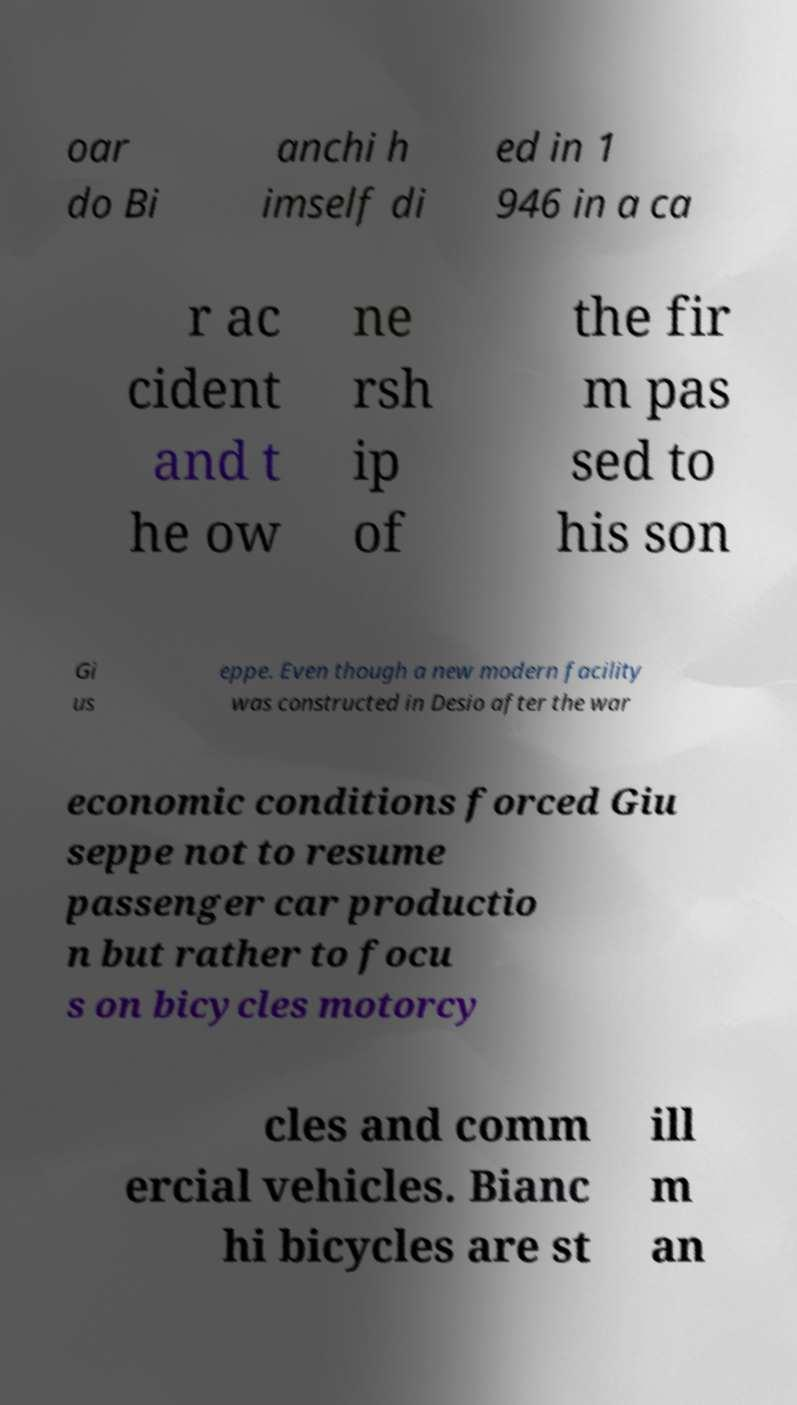Please identify and transcribe the text found in this image. oar do Bi anchi h imself di ed in 1 946 in a ca r ac cident and t he ow ne rsh ip of the fir m pas sed to his son Gi us eppe. Even though a new modern facility was constructed in Desio after the war economic conditions forced Giu seppe not to resume passenger car productio n but rather to focu s on bicycles motorcy cles and comm ercial vehicles. Bianc hi bicycles are st ill m an 